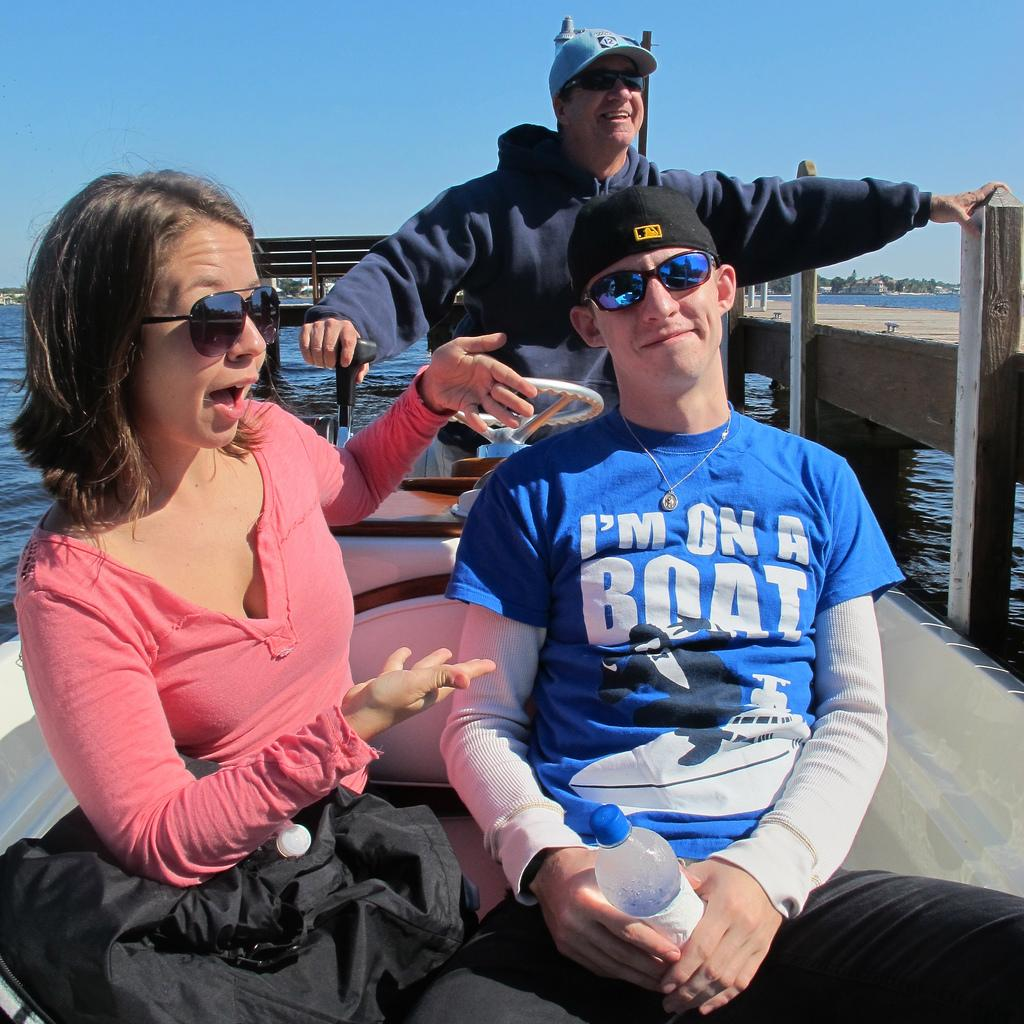Provide a one-sentence caption for the provided image. A young man on a boat wears a t-shirt which says he's on a boat. 